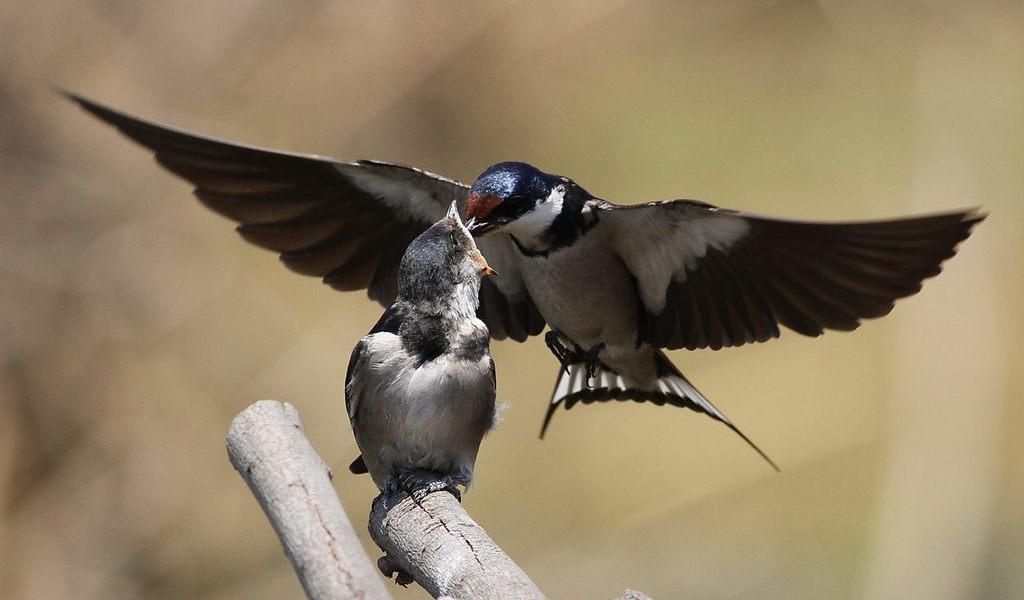How would you summarize this image in a sentence or two? In this picture there are two birds in the center of the image and there are two wooden bamboos at the bottom side of the image and the background area of the image is blur. 